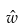<formula> <loc_0><loc_0><loc_500><loc_500>\hat { w }</formula> 